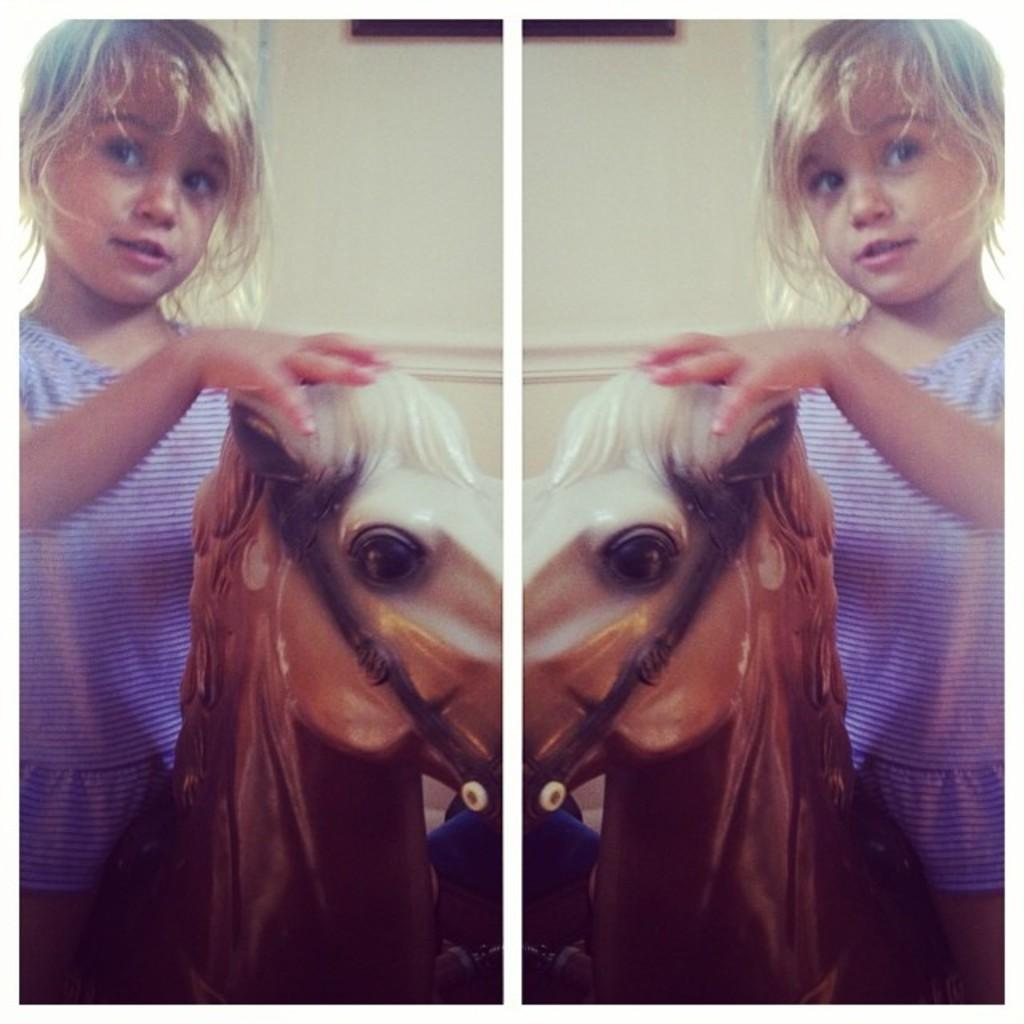Who is the main subject in the image? There is a girl in the image. What is the girl doing in the image? The girl is sitting on a horse. What can be seen in the background of the image? There is a wall in the background of the image. What type of experience does the creator of the horse have? There is no information about the creator of the horse in the image, and therefore no such experience can be determined. 